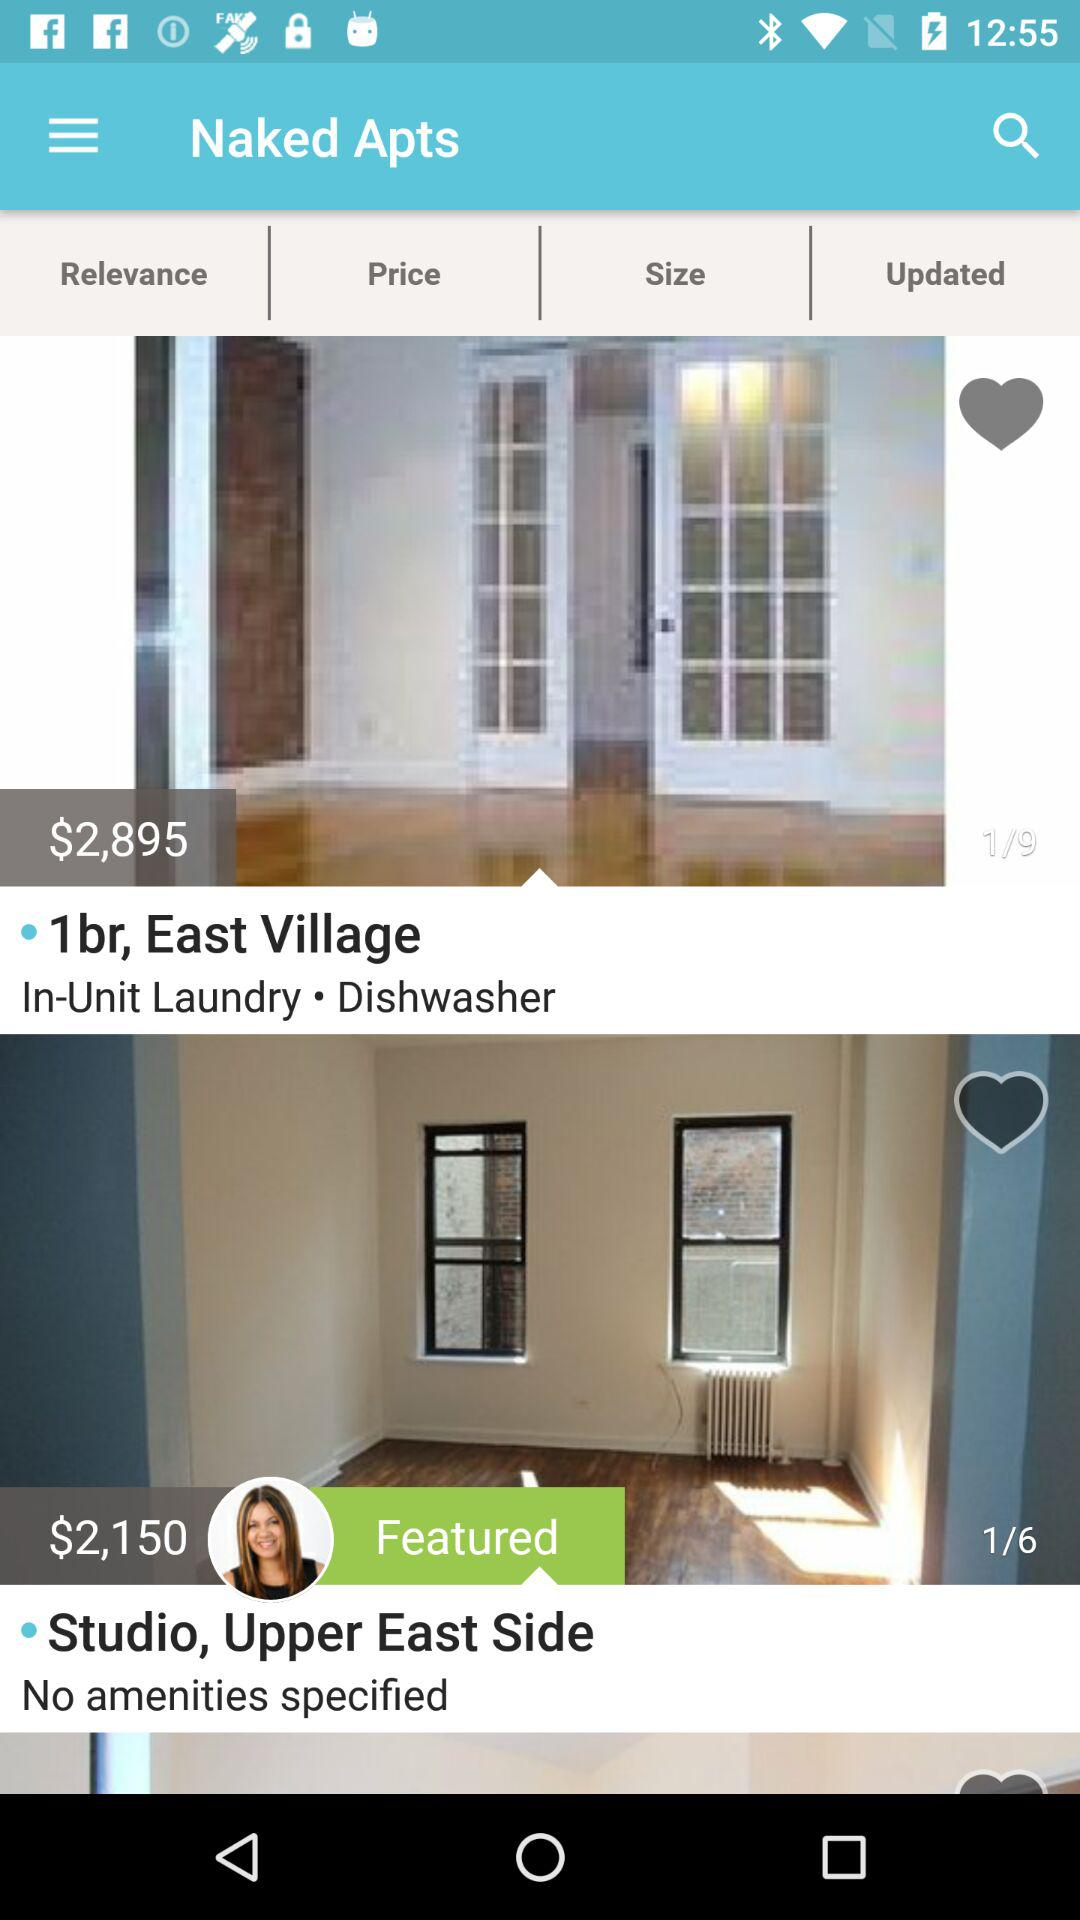What is the currency of a price? The currency of a price is dollars. 